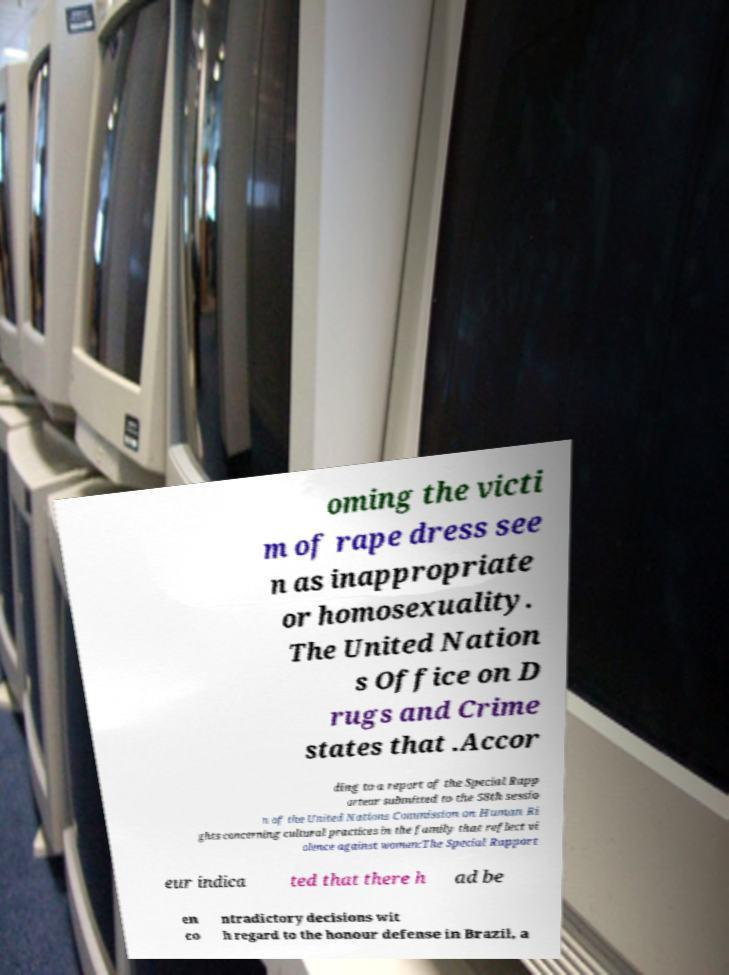For documentation purposes, I need the text within this image transcribed. Could you provide that? oming the victi m of rape dress see n as inappropriate or homosexuality. The United Nation s Office on D rugs and Crime states that .Accor ding to a report of the Special Rapp orteur submitted to the 58th sessio n of the United Nations Commission on Human Ri ghts concerning cultural practices in the family that reflect vi olence against women:The Special Rapport eur indica ted that there h ad be en co ntradictory decisions wit h regard to the honour defense in Brazil, a 